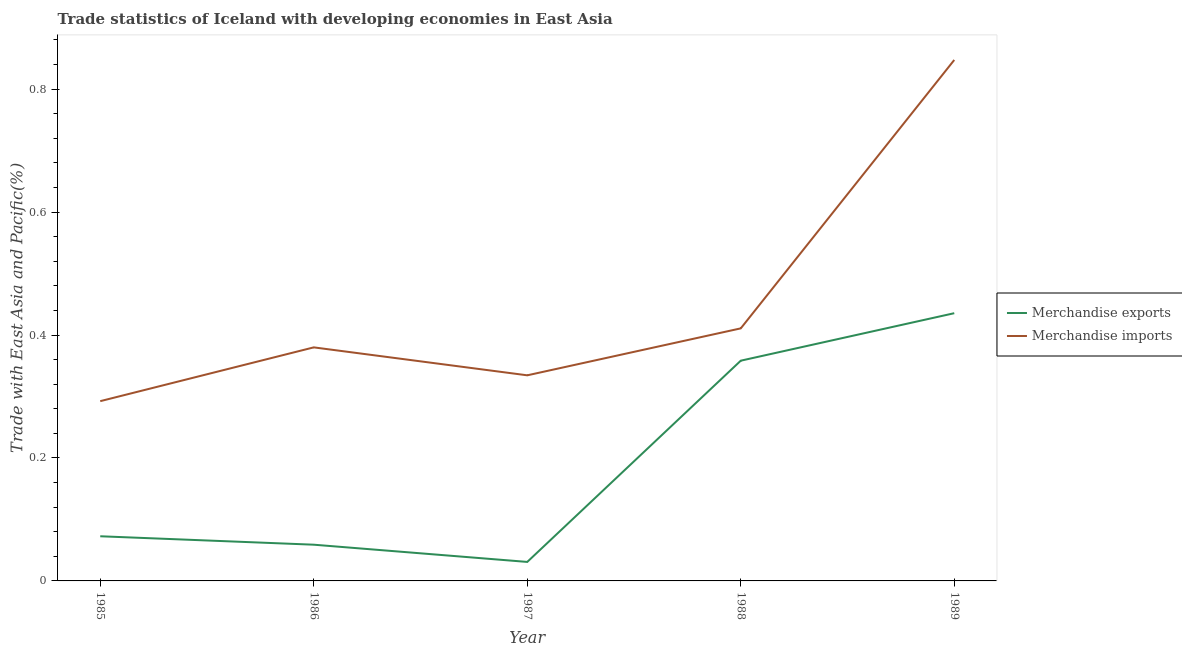How many different coloured lines are there?
Give a very brief answer. 2. Does the line corresponding to merchandise exports intersect with the line corresponding to merchandise imports?
Make the answer very short. No. Is the number of lines equal to the number of legend labels?
Keep it short and to the point. Yes. What is the merchandise imports in 1989?
Provide a short and direct response. 0.85. Across all years, what is the maximum merchandise exports?
Your answer should be very brief. 0.44. Across all years, what is the minimum merchandise imports?
Ensure brevity in your answer.  0.29. What is the total merchandise imports in the graph?
Keep it short and to the point. 2.26. What is the difference between the merchandise exports in 1987 and that in 1989?
Your answer should be very brief. -0.4. What is the difference between the merchandise exports in 1988 and the merchandise imports in 1986?
Keep it short and to the point. -0.02. What is the average merchandise exports per year?
Provide a succinct answer. 0.19. In the year 1987, what is the difference between the merchandise exports and merchandise imports?
Make the answer very short. -0.3. In how many years, is the merchandise imports greater than 0.12 %?
Your answer should be very brief. 5. What is the ratio of the merchandise imports in 1987 to that in 1988?
Ensure brevity in your answer.  0.81. Is the difference between the merchandise imports in 1986 and 1988 greater than the difference between the merchandise exports in 1986 and 1988?
Provide a succinct answer. Yes. What is the difference between the highest and the second highest merchandise imports?
Provide a short and direct response. 0.44. What is the difference between the highest and the lowest merchandise exports?
Keep it short and to the point. 0.4. In how many years, is the merchandise exports greater than the average merchandise exports taken over all years?
Offer a very short reply. 2. Is the sum of the merchandise imports in 1987 and 1988 greater than the maximum merchandise exports across all years?
Keep it short and to the point. Yes. Does the merchandise exports monotonically increase over the years?
Give a very brief answer. No. Is the merchandise imports strictly greater than the merchandise exports over the years?
Ensure brevity in your answer.  Yes. Is the merchandise exports strictly less than the merchandise imports over the years?
Provide a short and direct response. Yes. How many years are there in the graph?
Provide a succinct answer. 5. Does the graph contain grids?
Offer a very short reply. No. What is the title of the graph?
Provide a short and direct response. Trade statistics of Iceland with developing economies in East Asia. What is the label or title of the X-axis?
Make the answer very short. Year. What is the label or title of the Y-axis?
Provide a short and direct response. Trade with East Asia and Pacific(%). What is the Trade with East Asia and Pacific(%) in Merchandise exports in 1985?
Provide a short and direct response. 0.07. What is the Trade with East Asia and Pacific(%) of Merchandise imports in 1985?
Keep it short and to the point. 0.29. What is the Trade with East Asia and Pacific(%) of Merchandise exports in 1986?
Provide a succinct answer. 0.06. What is the Trade with East Asia and Pacific(%) in Merchandise imports in 1986?
Offer a terse response. 0.38. What is the Trade with East Asia and Pacific(%) of Merchandise exports in 1987?
Your response must be concise. 0.03. What is the Trade with East Asia and Pacific(%) in Merchandise imports in 1987?
Provide a succinct answer. 0.33. What is the Trade with East Asia and Pacific(%) of Merchandise exports in 1988?
Make the answer very short. 0.36. What is the Trade with East Asia and Pacific(%) of Merchandise imports in 1988?
Your response must be concise. 0.41. What is the Trade with East Asia and Pacific(%) in Merchandise exports in 1989?
Provide a succinct answer. 0.44. What is the Trade with East Asia and Pacific(%) in Merchandise imports in 1989?
Give a very brief answer. 0.85. Across all years, what is the maximum Trade with East Asia and Pacific(%) of Merchandise exports?
Provide a succinct answer. 0.44. Across all years, what is the maximum Trade with East Asia and Pacific(%) in Merchandise imports?
Provide a short and direct response. 0.85. Across all years, what is the minimum Trade with East Asia and Pacific(%) of Merchandise exports?
Ensure brevity in your answer.  0.03. Across all years, what is the minimum Trade with East Asia and Pacific(%) of Merchandise imports?
Offer a terse response. 0.29. What is the total Trade with East Asia and Pacific(%) of Merchandise exports in the graph?
Make the answer very short. 0.96. What is the total Trade with East Asia and Pacific(%) in Merchandise imports in the graph?
Your answer should be very brief. 2.27. What is the difference between the Trade with East Asia and Pacific(%) of Merchandise exports in 1985 and that in 1986?
Your answer should be compact. 0.01. What is the difference between the Trade with East Asia and Pacific(%) of Merchandise imports in 1985 and that in 1986?
Ensure brevity in your answer.  -0.09. What is the difference between the Trade with East Asia and Pacific(%) in Merchandise exports in 1985 and that in 1987?
Your answer should be compact. 0.04. What is the difference between the Trade with East Asia and Pacific(%) of Merchandise imports in 1985 and that in 1987?
Offer a terse response. -0.04. What is the difference between the Trade with East Asia and Pacific(%) in Merchandise exports in 1985 and that in 1988?
Provide a succinct answer. -0.29. What is the difference between the Trade with East Asia and Pacific(%) of Merchandise imports in 1985 and that in 1988?
Offer a terse response. -0.12. What is the difference between the Trade with East Asia and Pacific(%) of Merchandise exports in 1985 and that in 1989?
Provide a short and direct response. -0.36. What is the difference between the Trade with East Asia and Pacific(%) in Merchandise imports in 1985 and that in 1989?
Offer a very short reply. -0.56. What is the difference between the Trade with East Asia and Pacific(%) of Merchandise exports in 1986 and that in 1987?
Provide a succinct answer. 0.03. What is the difference between the Trade with East Asia and Pacific(%) of Merchandise imports in 1986 and that in 1987?
Give a very brief answer. 0.05. What is the difference between the Trade with East Asia and Pacific(%) of Merchandise exports in 1986 and that in 1988?
Provide a succinct answer. -0.3. What is the difference between the Trade with East Asia and Pacific(%) of Merchandise imports in 1986 and that in 1988?
Offer a very short reply. -0.03. What is the difference between the Trade with East Asia and Pacific(%) of Merchandise exports in 1986 and that in 1989?
Your answer should be compact. -0.38. What is the difference between the Trade with East Asia and Pacific(%) in Merchandise imports in 1986 and that in 1989?
Offer a terse response. -0.47. What is the difference between the Trade with East Asia and Pacific(%) of Merchandise exports in 1987 and that in 1988?
Ensure brevity in your answer.  -0.33. What is the difference between the Trade with East Asia and Pacific(%) in Merchandise imports in 1987 and that in 1988?
Your answer should be very brief. -0.08. What is the difference between the Trade with East Asia and Pacific(%) of Merchandise exports in 1987 and that in 1989?
Provide a short and direct response. -0.4. What is the difference between the Trade with East Asia and Pacific(%) of Merchandise imports in 1987 and that in 1989?
Keep it short and to the point. -0.51. What is the difference between the Trade with East Asia and Pacific(%) of Merchandise exports in 1988 and that in 1989?
Your answer should be compact. -0.08. What is the difference between the Trade with East Asia and Pacific(%) of Merchandise imports in 1988 and that in 1989?
Ensure brevity in your answer.  -0.44. What is the difference between the Trade with East Asia and Pacific(%) in Merchandise exports in 1985 and the Trade with East Asia and Pacific(%) in Merchandise imports in 1986?
Give a very brief answer. -0.31. What is the difference between the Trade with East Asia and Pacific(%) in Merchandise exports in 1985 and the Trade with East Asia and Pacific(%) in Merchandise imports in 1987?
Keep it short and to the point. -0.26. What is the difference between the Trade with East Asia and Pacific(%) in Merchandise exports in 1985 and the Trade with East Asia and Pacific(%) in Merchandise imports in 1988?
Your answer should be very brief. -0.34. What is the difference between the Trade with East Asia and Pacific(%) of Merchandise exports in 1985 and the Trade with East Asia and Pacific(%) of Merchandise imports in 1989?
Your response must be concise. -0.77. What is the difference between the Trade with East Asia and Pacific(%) of Merchandise exports in 1986 and the Trade with East Asia and Pacific(%) of Merchandise imports in 1987?
Offer a very short reply. -0.28. What is the difference between the Trade with East Asia and Pacific(%) of Merchandise exports in 1986 and the Trade with East Asia and Pacific(%) of Merchandise imports in 1988?
Make the answer very short. -0.35. What is the difference between the Trade with East Asia and Pacific(%) of Merchandise exports in 1986 and the Trade with East Asia and Pacific(%) of Merchandise imports in 1989?
Offer a very short reply. -0.79. What is the difference between the Trade with East Asia and Pacific(%) of Merchandise exports in 1987 and the Trade with East Asia and Pacific(%) of Merchandise imports in 1988?
Your answer should be compact. -0.38. What is the difference between the Trade with East Asia and Pacific(%) in Merchandise exports in 1987 and the Trade with East Asia and Pacific(%) in Merchandise imports in 1989?
Offer a terse response. -0.82. What is the difference between the Trade with East Asia and Pacific(%) in Merchandise exports in 1988 and the Trade with East Asia and Pacific(%) in Merchandise imports in 1989?
Your response must be concise. -0.49. What is the average Trade with East Asia and Pacific(%) of Merchandise exports per year?
Your response must be concise. 0.19. What is the average Trade with East Asia and Pacific(%) of Merchandise imports per year?
Make the answer very short. 0.45. In the year 1985, what is the difference between the Trade with East Asia and Pacific(%) of Merchandise exports and Trade with East Asia and Pacific(%) of Merchandise imports?
Provide a short and direct response. -0.22. In the year 1986, what is the difference between the Trade with East Asia and Pacific(%) of Merchandise exports and Trade with East Asia and Pacific(%) of Merchandise imports?
Your answer should be very brief. -0.32. In the year 1987, what is the difference between the Trade with East Asia and Pacific(%) in Merchandise exports and Trade with East Asia and Pacific(%) in Merchandise imports?
Your response must be concise. -0.3. In the year 1988, what is the difference between the Trade with East Asia and Pacific(%) of Merchandise exports and Trade with East Asia and Pacific(%) of Merchandise imports?
Keep it short and to the point. -0.05. In the year 1989, what is the difference between the Trade with East Asia and Pacific(%) of Merchandise exports and Trade with East Asia and Pacific(%) of Merchandise imports?
Provide a succinct answer. -0.41. What is the ratio of the Trade with East Asia and Pacific(%) of Merchandise exports in 1985 to that in 1986?
Your answer should be very brief. 1.23. What is the ratio of the Trade with East Asia and Pacific(%) of Merchandise imports in 1985 to that in 1986?
Give a very brief answer. 0.77. What is the ratio of the Trade with East Asia and Pacific(%) in Merchandise exports in 1985 to that in 1987?
Provide a succinct answer. 2.35. What is the ratio of the Trade with East Asia and Pacific(%) in Merchandise imports in 1985 to that in 1987?
Give a very brief answer. 0.87. What is the ratio of the Trade with East Asia and Pacific(%) of Merchandise exports in 1985 to that in 1988?
Give a very brief answer. 0.2. What is the ratio of the Trade with East Asia and Pacific(%) of Merchandise imports in 1985 to that in 1988?
Provide a short and direct response. 0.71. What is the ratio of the Trade with East Asia and Pacific(%) of Merchandise exports in 1985 to that in 1989?
Provide a succinct answer. 0.17. What is the ratio of the Trade with East Asia and Pacific(%) of Merchandise imports in 1985 to that in 1989?
Your answer should be compact. 0.35. What is the ratio of the Trade with East Asia and Pacific(%) in Merchandise exports in 1986 to that in 1987?
Offer a terse response. 1.91. What is the ratio of the Trade with East Asia and Pacific(%) of Merchandise imports in 1986 to that in 1987?
Offer a terse response. 1.14. What is the ratio of the Trade with East Asia and Pacific(%) in Merchandise exports in 1986 to that in 1988?
Offer a terse response. 0.16. What is the ratio of the Trade with East Asia and Pacific(%) of Merchandise imports in 1986 to that in 1988?
Your answer should be compact. 0.92. What is the ratio of the Trade with East Asia and Pacific(%) of Merchandise exports in 1986 to that in 1989?
Your response must be concise. 0.14. What is the ratio of the Trade with East Asia and Pacific(%) of Merchandise imports in 1986 to that in 1989?
Offer a very short reply. 0.45. What is the ratio of the Trade with East Asia and Pacific(%) in Merchandise exports in 1987 to that in 1988?
Give a very brief answer. 0.09. What is the ratio of the Trade with East Asia and Pacific(%) in Merchandise imports in 1987 to that in 1988?
Offer a very short reply. 0.81. What is the ratio of the Trade with East Asia and Pacific(%) in Merchandise exports in 1987 to that in 1989?
Make the answer very short. 0.07. What is the ratio of the Trade with East Asia and Pacific(%) of Merchandise imports in 1987 to that in 1989?
Provide a succinct answer. 0.39. What is the ratio of the Trade with East Asia and Pacific(%) of Merchandise exports in 1988 to that in 1989?
Your response must be concise. 0.82. What is the ratio of the Trade with East Asia and Pacific(%) of Merchandise imports in 1988 to that in 1989?
Offer a terse response. 0.48. What is the difference between the highest and the second highest Trade with East Asia and Pacific(%) of Merchandise exports?
Your answer should be very brief. 0.08. What is the difference between the highest and the second highest Trade with East Asia and Pacific(%) of Merchandise imports?
Ensure brevity in your answer.  0.44. What is the difference between the highest and the lowest Trade with East Asia and Pacific(%) of Merchandise exports?
Your answer should be compact. 0.4. What is the difference between the highest and the lowest Trade with East Asia and Pacific(%) in Merchandise imports?
Make the answer very short. 0.56. 